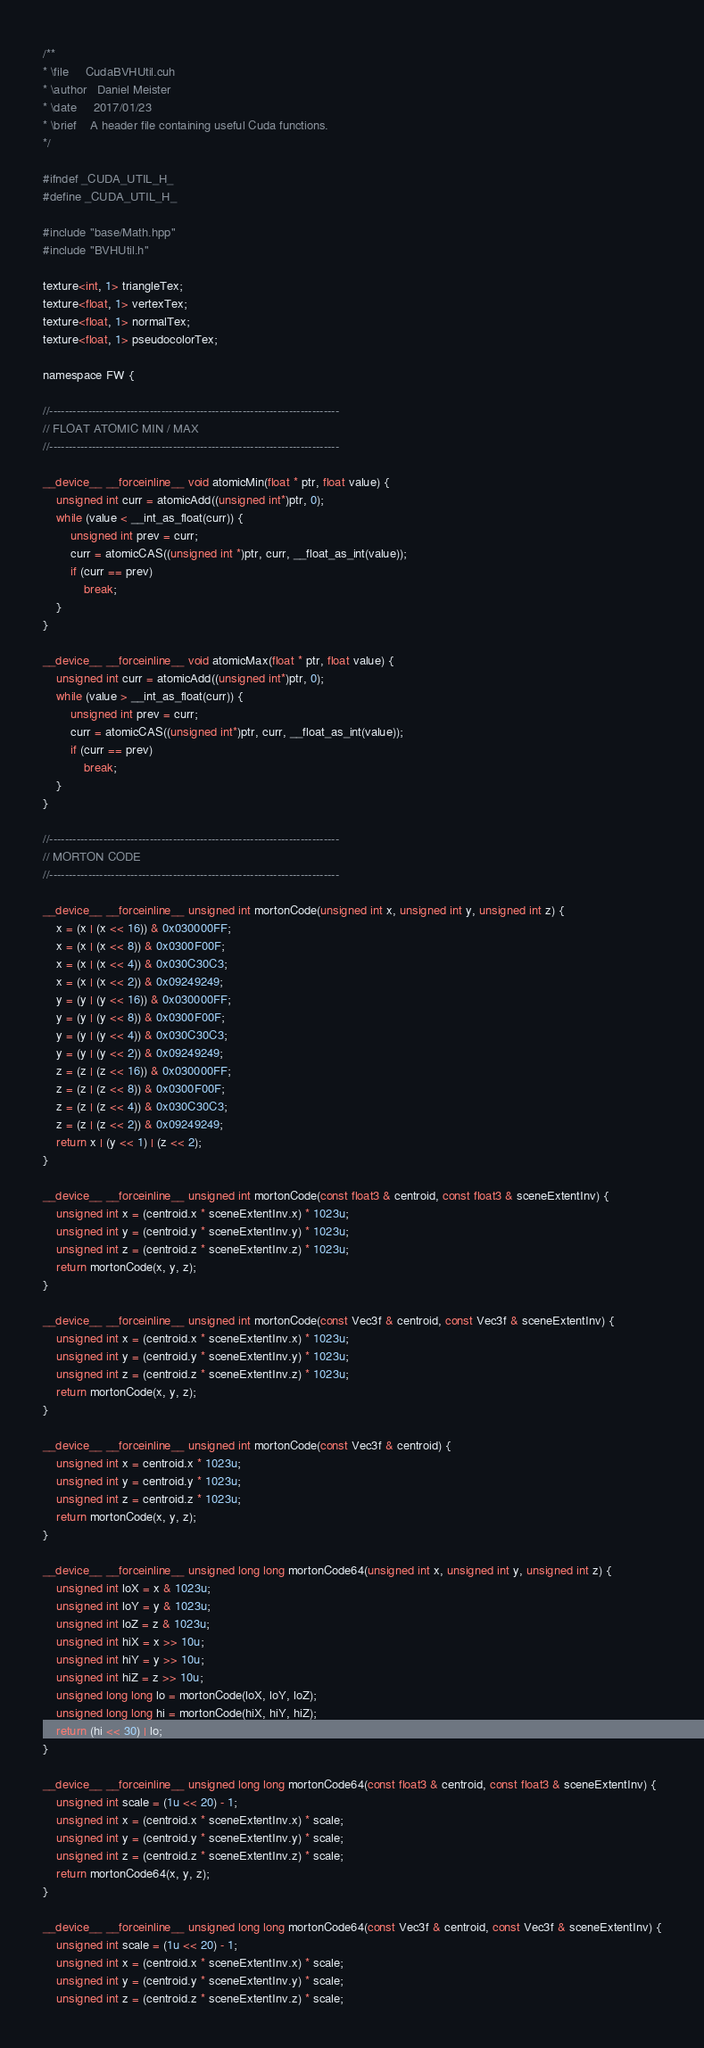<code> <loc_0><loc_0><loc_500><loc_500><_Cuda_>/**
* \file		CudaBVHUtil.cuh
* \author	Daniel Meister
* \date		2017/01/23
* \brief	A header file containing useful Cuda functions.
*/

#ifndef _CUDA_UTIL_H_
#define _CUDA_UTIL_H_

#include "base/Math.hpp"
#include "BVHUtil.h"

texture<int, 1> triangleTex;
texture<float, 1> vertexTex;
texture<float, 1> normalTex;
texture<float, 1> pseudocolorTex;

namespace FW {

//---------------------------------------------------------------------------
// FLOAT ATOMIC MIN / MAX
//---------------------------------------------------------------------------
	
__device__ __forceinline__ void atomicMin(float * ptr, float value) {
	unsigned int curr = atomicAdd((unsigned int*)ptr, 0);
	while (value < __int_as_float(curr)) {
		unsigned int prev = curr;
		curr = atomicCAS((unsigned int *)ptr, curr, __float_as_int(value));
		if (curr == prev)
			break;
	}
}

__device__ __forceinline__ void atomicMax(float * ptr, float value) {
	unsigned int curr = atomicAdd((unsigned int*)ptr, 0);
	while (value > __int_as_float(curr)) {
		unsigned int prev = curr;
		curr = atomicCAS((unsigned int*)ptr, curr, __float_as_int(value));
		if (curr == prev)
			break;
	}
}

//---------------------------------------------------------------------------
// MORTON CODE
//---------------------------------------------------------------------------

__device__ __forceinline__ unsigned int mortonCode(unsigned int x, unsigned int y, unsigned int z) {
	x = (x | (x << 16)) & 0x030000FF;
	x = (x | (x << 8)) & 0x0300F00F;
	x = (x | (x << 4)) & 0x030C30C3;
	x = (x | (x << 2)) & 0x09249249;
	y = (y | (y << 16)) & 0x030000FF;
	y = (y | (y << 8)) & 0x0300F00F;
	y = (y | (y << 4)) & 0x030C30C3;
	y = (y | (y << 2)) & 0x09249249;
	z = (z | (z << 16)) & 0x030000FF;
	z = (z | (z << 8)) & 0x0300F00F;
	z = (z | (z << 4)) & 0x030C30C3;
	z = (z | (z << 2)) & 0x09249249;
	return x | (y << 1) | (z << 2);
}

__device__ __forceinline__ unsigned int mortonCode(const float3 & centroid, const float3 & sceneExtentInv) {
	unsigned int x = (centroid.x * sceneExtentInv.x) * 1023u;
	unsigned int y = (centroid.y * sceneExtentInv.y) * 1023u;
	unsigned int z = (centroid.z * sceneExtentInv.z) * 1023u;
	return mortonCode(x, y, z);
}

__device__ __forceinline__ unsigned int mortonCode(const Vec3f & centroid, const Vec3f & sceneExtentInv) {
	unsigned int x = (centroid.x * sceneExtentInv.x) * 1023u;
	unsigned int y = (centroid.y * sceneExtentInv.y) * 1023u;
	unsigned int z = (centroid.z * sceneExtentInv.z) * 1023u;
	return mortonCode(x, y, z);
}

__device__ __forceinline__ unsigned int mortonCode(const Vec3f & centroid) {
	unsigned int x = centroid.x * 1023u;
	unsigned int y = centroid.y * 1023u;
	unsigned int z = centroid.z * 1023u;
	return mortonCode(x, y, z);
}

__device__ __forceinline__ unsigned long long mortonCode64(unsigned int x, unsigned int y, unsigned int z) {
	unsigned int loX = x & 1023u;
	unsigned int loY = y & 1023u;
	unsigned int loZ = z & 1023u;
	unsigned int hiX = x >> 10u;
	unsigned int hiY = y >> 10u;
	unsigned int hiZ = z >> 10u;
	unsigned long long lo = mortonCode(loX, loY, loZ);
	unsigned long long hi = mortonCode(hiX, hiY, hiZ);
	return (hi << 30) | lo;
}

__device__ __forceinline__ unsigned long long mortonCode64(const float3 & centroid, const float3 & sceneExtentInv) {
	unsigned int scale = (1u << 20) - 1;
	unsigned int x = (centroid.x * sceneExtentInv.x) * scale;
	unsigned int y = (centroid.y * sceneExtentInv.y) * scale;
	unsigned int z = (centroid.z * sceneExtentInv.z) * scale;
	return mortonCode64(x, y, z);
}

__device__ __forceinline__ unsigned long long mortonCode64(const Vec3f & centroid, const Vec3f & sceneExtentInv) {
	unsigned int scale = (1u << 20) - 1;
	unsigned int x = (centroid.x * sceneExtentInv.x) * scale;
	unsigned int y = (centroid.y * sceneExtentInv.y) * scale;
	unsigned int z = (centroid.z * sceneExtentInv.z) * scale;</code> 